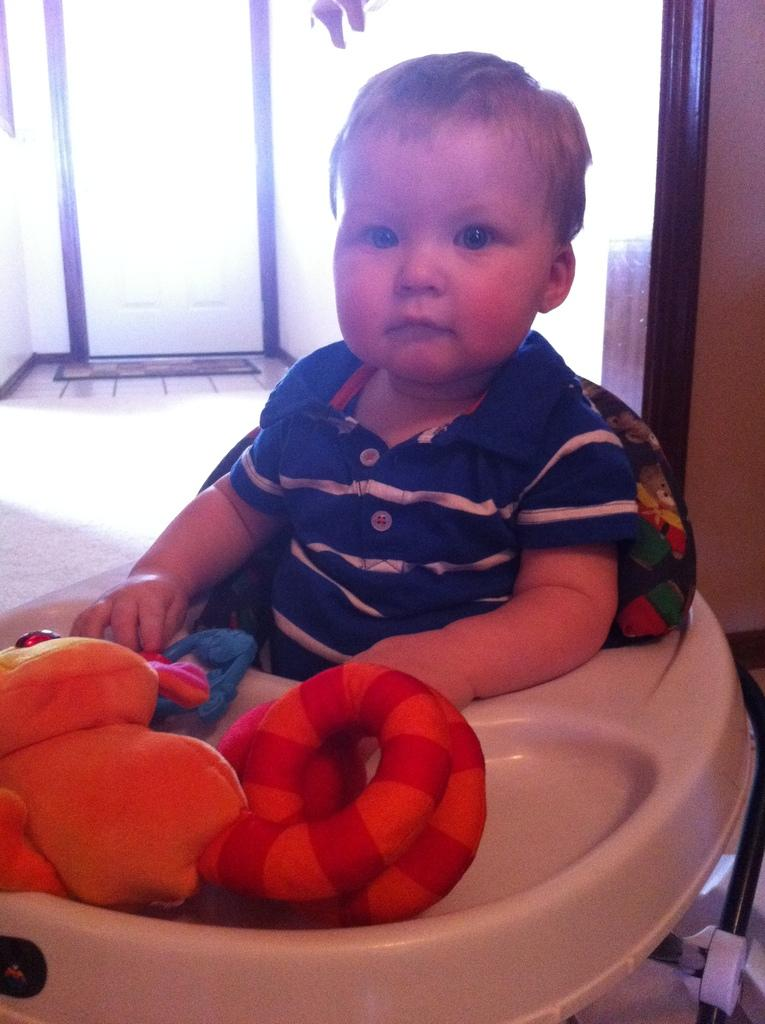What is the kid doing in the image? The kid is sitting on a chair in the image. What is in front of the kid? There are toys in front of the kid. What can be seen in the background of the image? There is a wall in the background of the image. Is there any entrance or exit visible in the wall? Yes, there is a door in the wall. What type of cable is the kid using to trip in the image? There is no cable present in the image, and the kid is not tripping. 